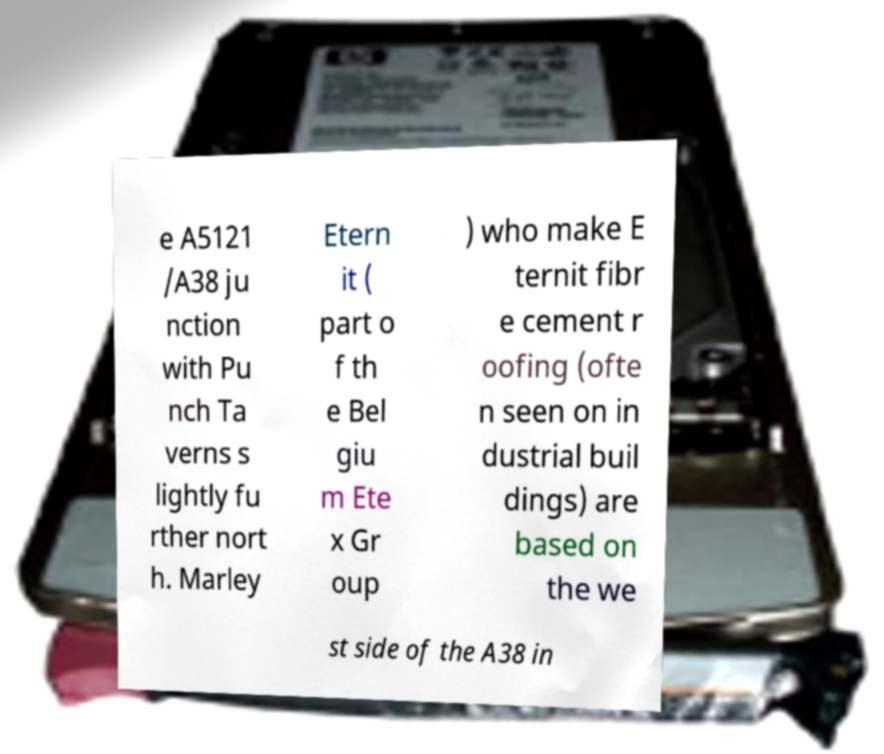Could you assist in decoding the text presented in this image and type it out clearly? e A5121 /A38 ju nction with Pu nch Ta verns s lightly fu rther nort h. Marley Etern it ( part o f th e Bel giu m Ete x Gr oup ) who make E ternit fibr e cement r oofing (ofte n seen on in dustrial buil dings) are based on the we st side of the A38 in 